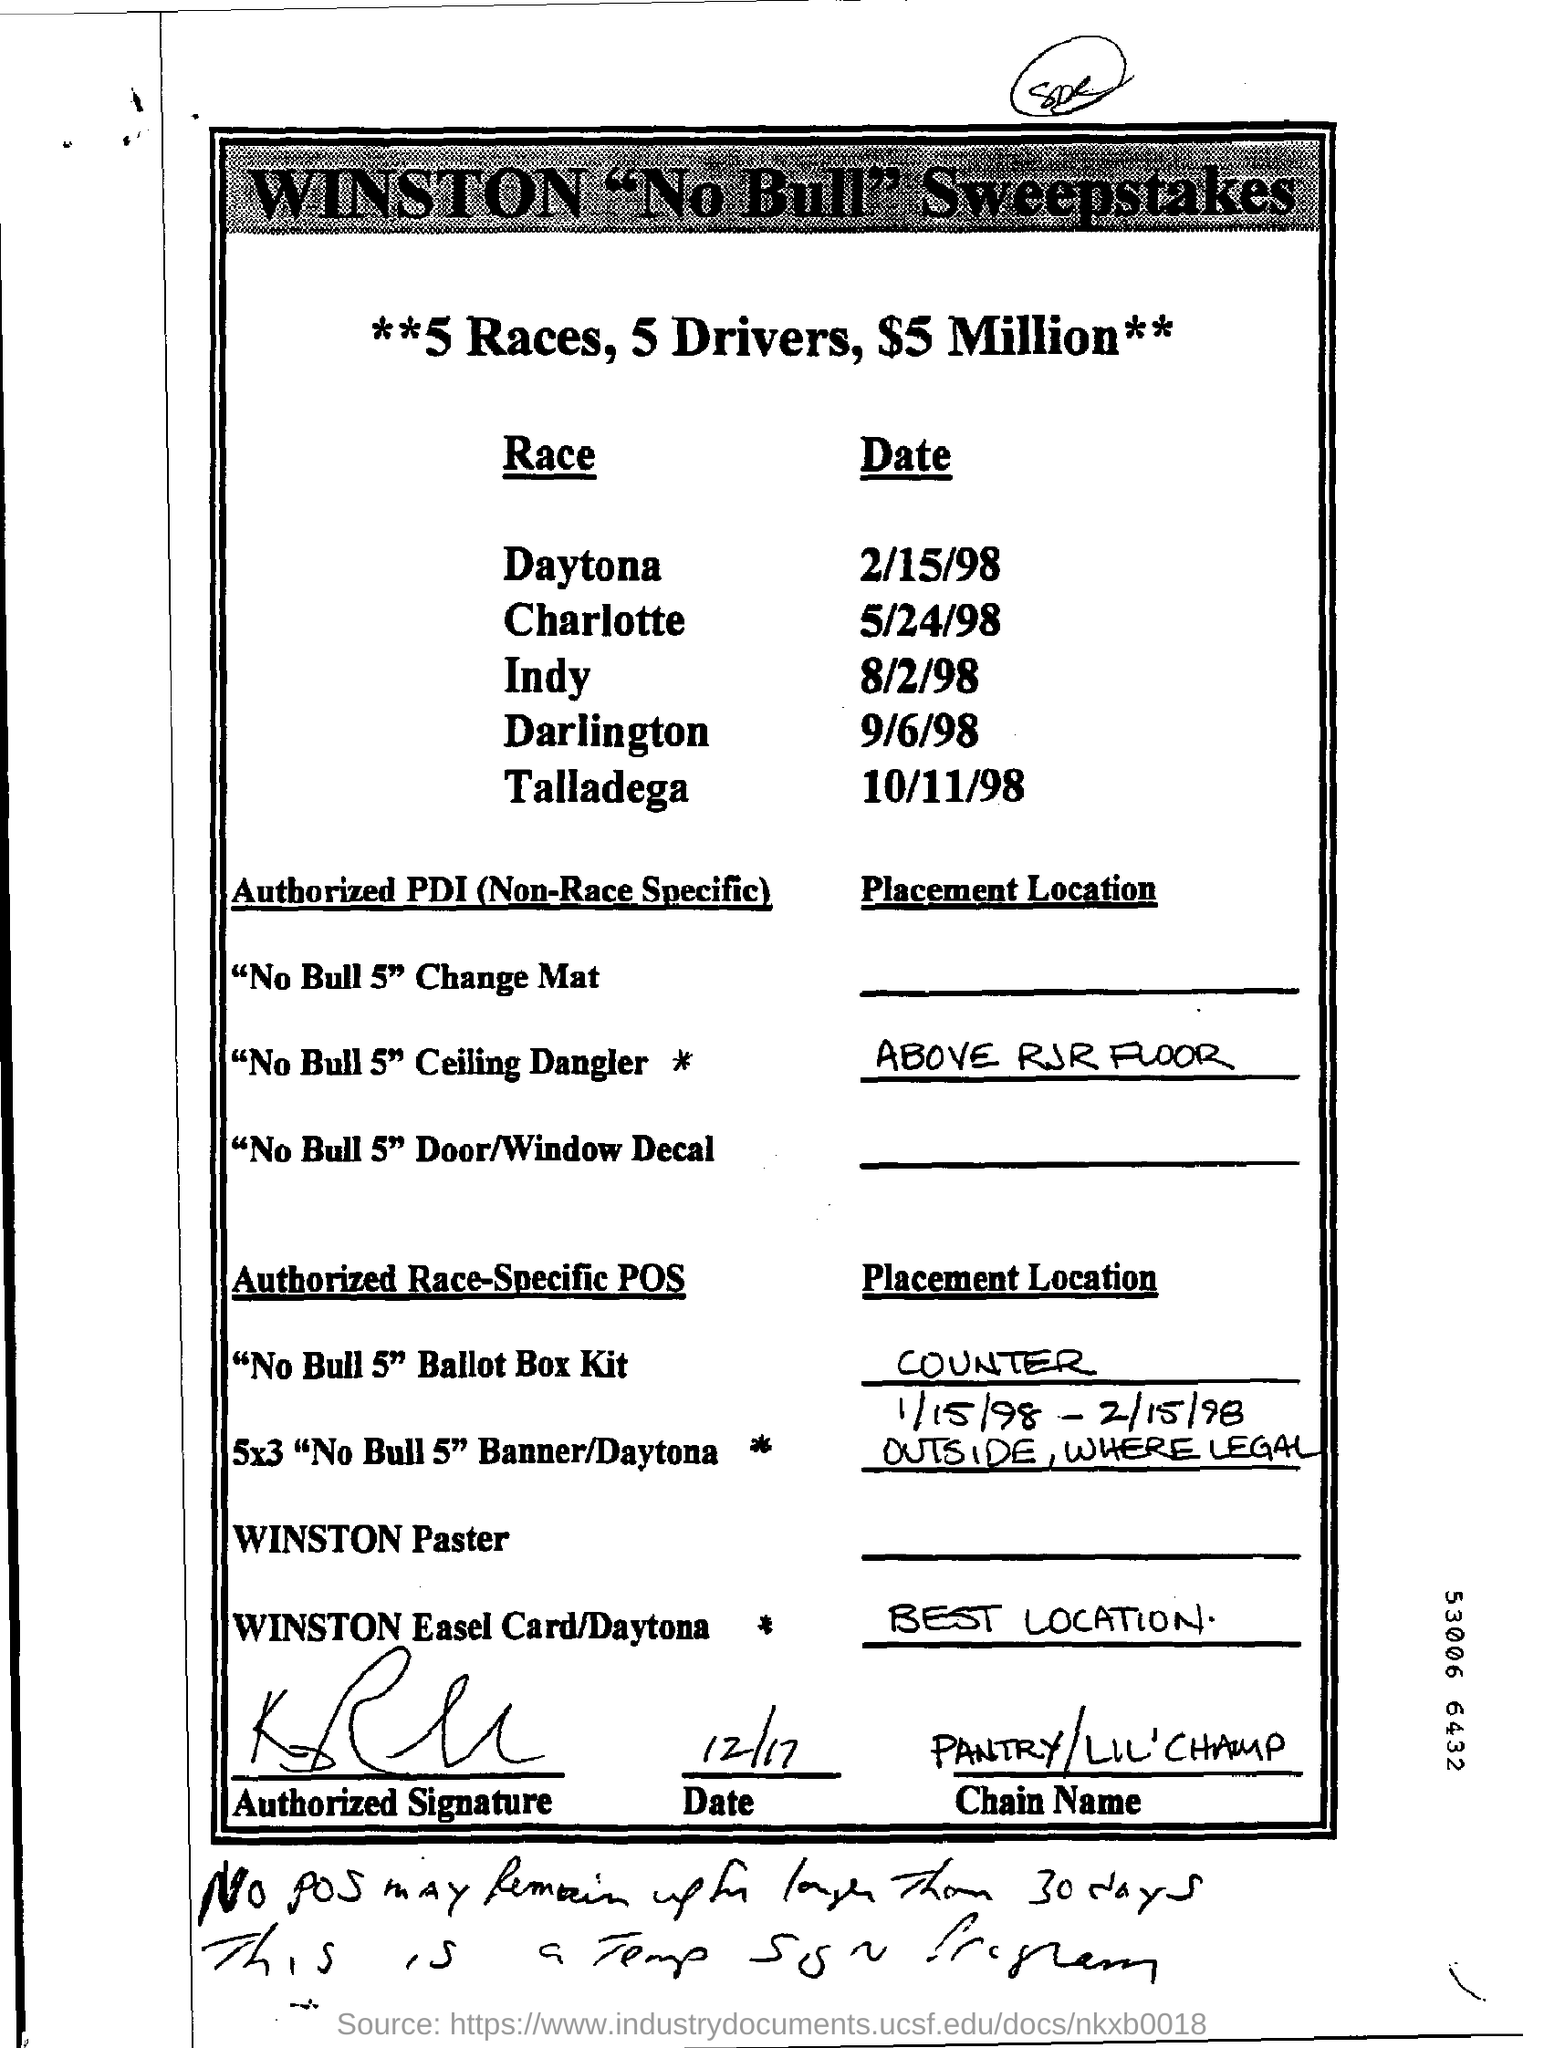Specify some key components in this picture. The location of "No Bull 5" Ceiling Dangler is above the RJR Floor. The Indy race is scheduled for August 2, 1998. The chain name is Pantry/Lil' Champ. The Daytona race is scheduled to take place on February 15, 1998. 